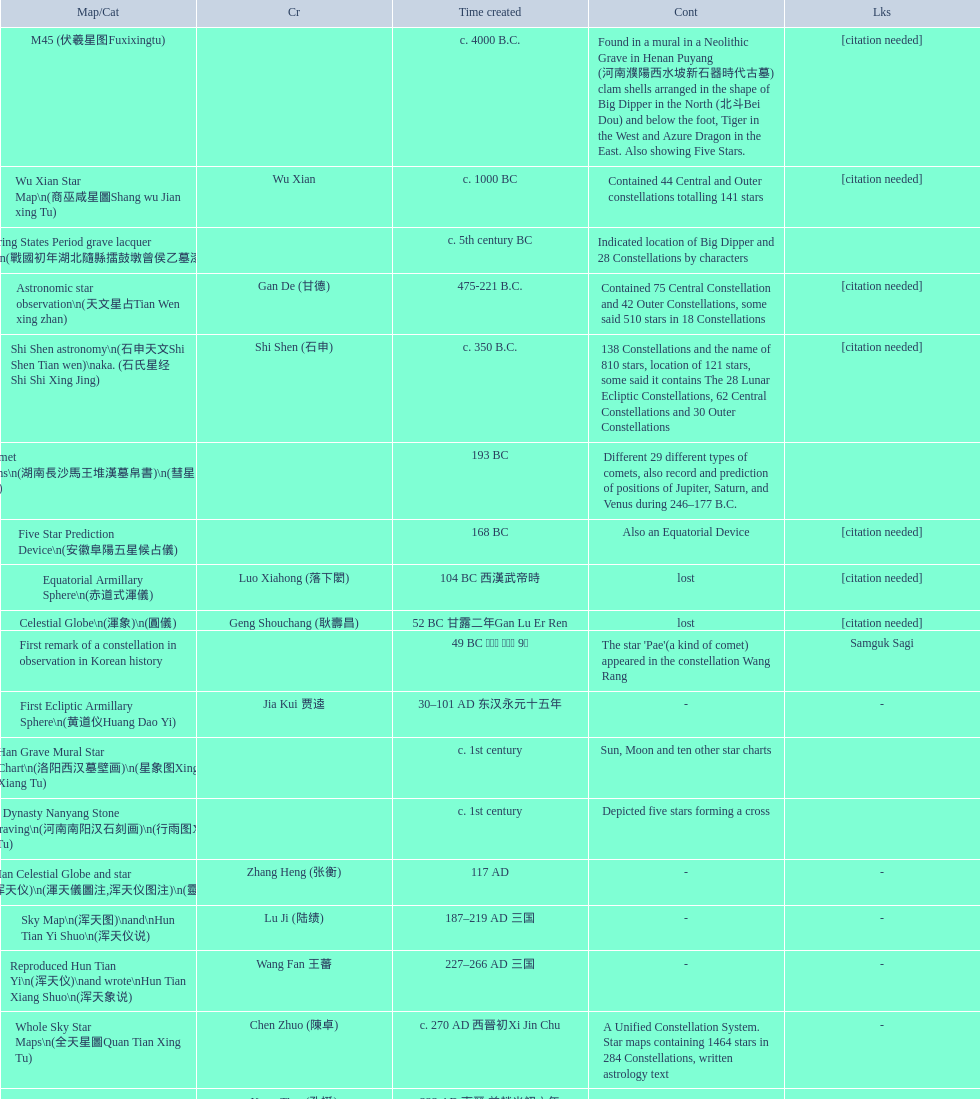What is the name of the oldest map/catalog? M45. 